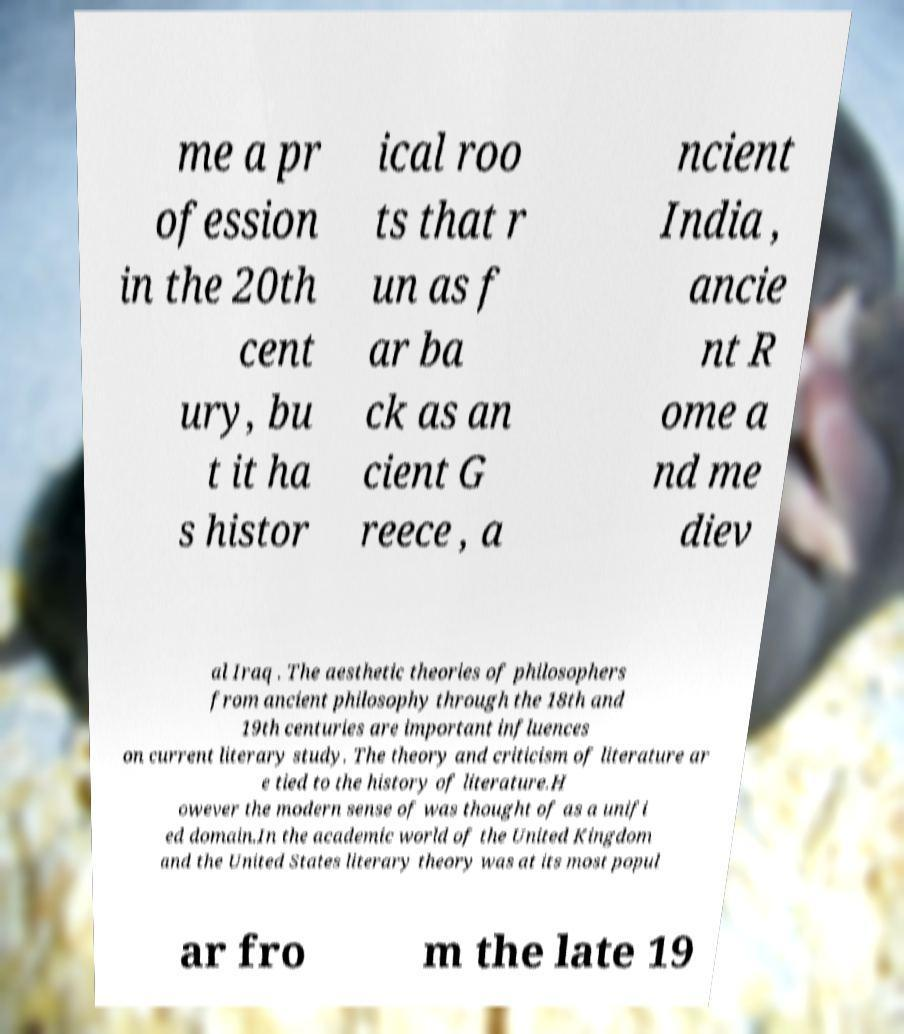I need the written content from this picture converted into text. Can you do that? me a pr ofession in the 20th cent ury, bu t it ha s histor ical roo ts that r un as f ar ba ck as an cient G reece , a ncient India , ancie nt R ome a nd me diev al Iraq . The aesthetic theories of philosophers from ancient philosophy through the 18th and 19th centuries are important influences on current literary study. The theory and criticism of literature ar e tied to the history of literature.H owever the modern sense of was thought of as a unifi ed domain.In the academic world of the United Kingdom and the United States literary theory was at its most popul ar fro m the late 19 